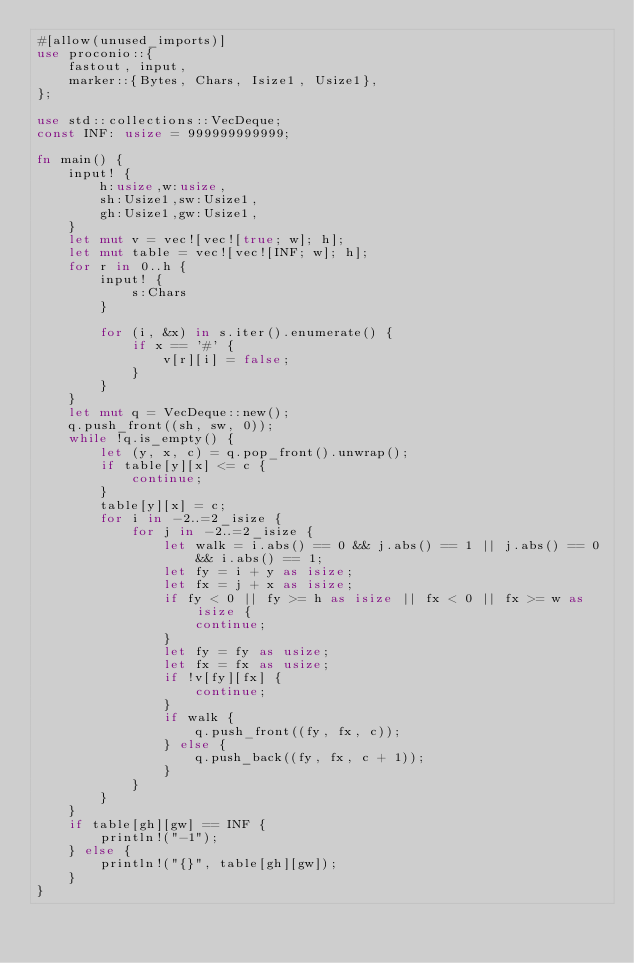<code> <loc_0><loc_0><loc_500><loc_500><_Rust_>#[allow(unused_imports)]
use proconio::{
    fastout, input,
    marker::{Bytes, Chars, Isize1, Usize1},
};

use std::collections::VecDeque;
const INF: usize = 999999999999;

fn main() {
    input! {
        h:usize,w:usize,
        sh:Usize1,sw:Usize1,
        gh:Usize1,gw:Usize1,
    }
    let mut v = vec![vec![true; w]; h];
    let mut table = vec![vec![INF; w]; h];
    for r in 0..h {
        input! {
            s:Chars
        }

        for (i, &x) in s.iter().enumerate() {
            if x == '#' {
                v[r][i] = false;
            }
        }
    }
    let mut q = VecDeque::new();
    q.push_front((sh, sw, 0));
    while !q.is_empty() {
        let (y, x, c) = q.pop_front().unwrap();
        if table[y][x] <= c {
            continue;
        }
        table[y][x] = c;
        for i in -2..=2_isize {
            for j in -2..=2_isize {
                let walk = i.abs() == 0 && j.abs() == 1 || j.abs() == 0 && i.abs() == 1;
                let fy = i + y as isize;
                let fx = j + x as isize;
                if fy < 0 || fy >= h as isize || fx < 0 || fx >= w as isize {
                    continue;
                }
                let fy = fy as usize;
                let fx = fx as usize;
                if !v[fy][fx] {
                    continue;
                }
                if walk {
                    q.push_front((fy, fx, c));
                } else {
                    q.push_back((fy, fx, c + 1));
                }
            }
        }
    }
    if table[gh][gw] == INF {
        println!("-1");
    } else {
        println!("{}", table[gh][gw]);
    }
}
</code> 